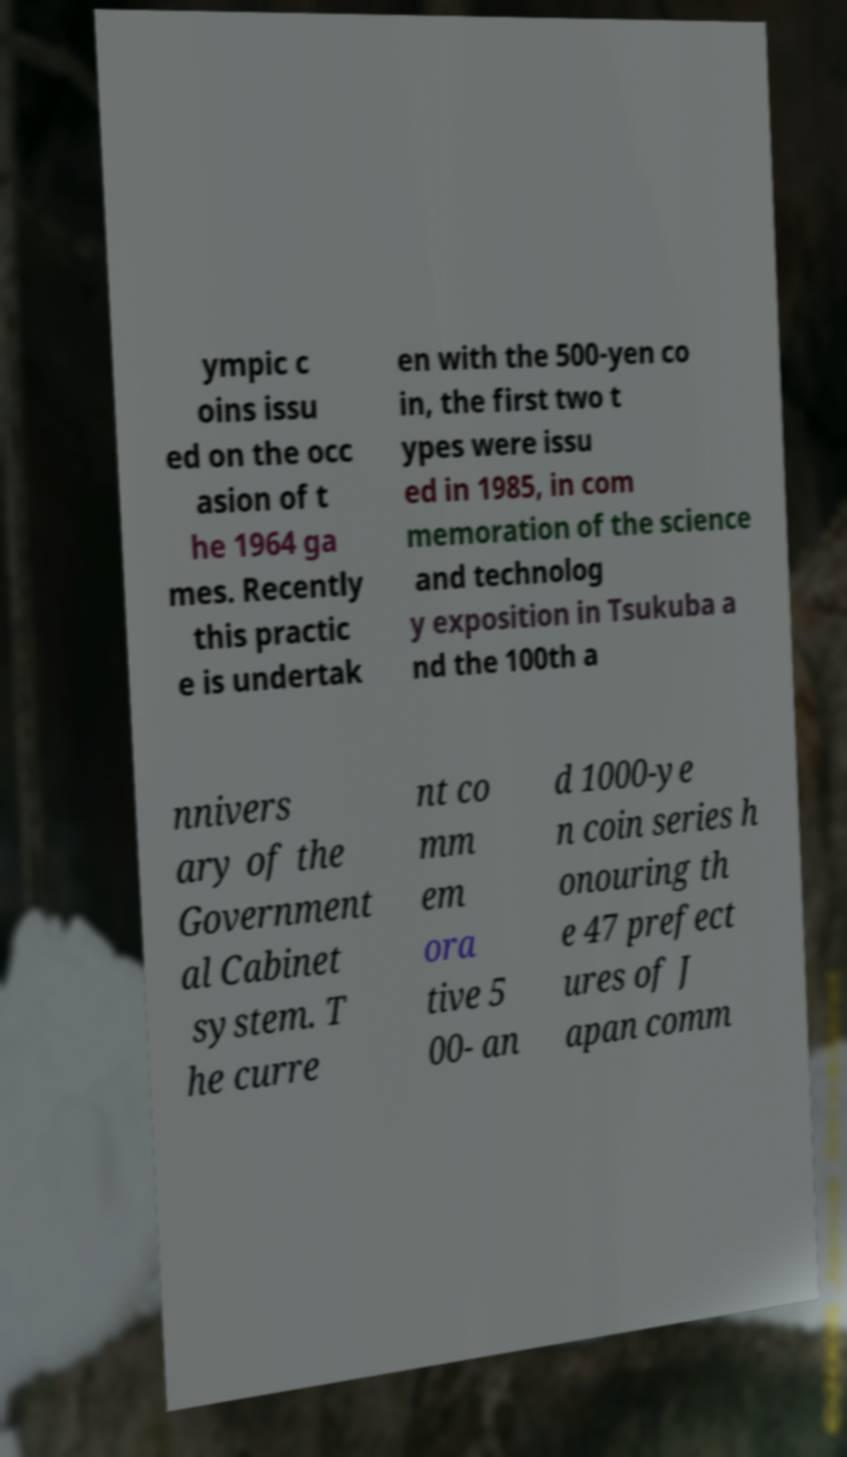Please identify and transcribe the text found in this image. ympic c oins issu ed on the occ asion of t he 1964 ga mes. Recently this practic e is undertak en with the 500-yen co in, the first two t ypes were issu ed in 1985, in com memoration of the science and technolog y exposition in Tsukuba a nd the 100th a nnivers ary of the Government al Cabinet system. T he curre nt co mm em ora tive 5 00- an d 1000-ye n coin series h onouring th e 47 prefect ures of J apan comm 